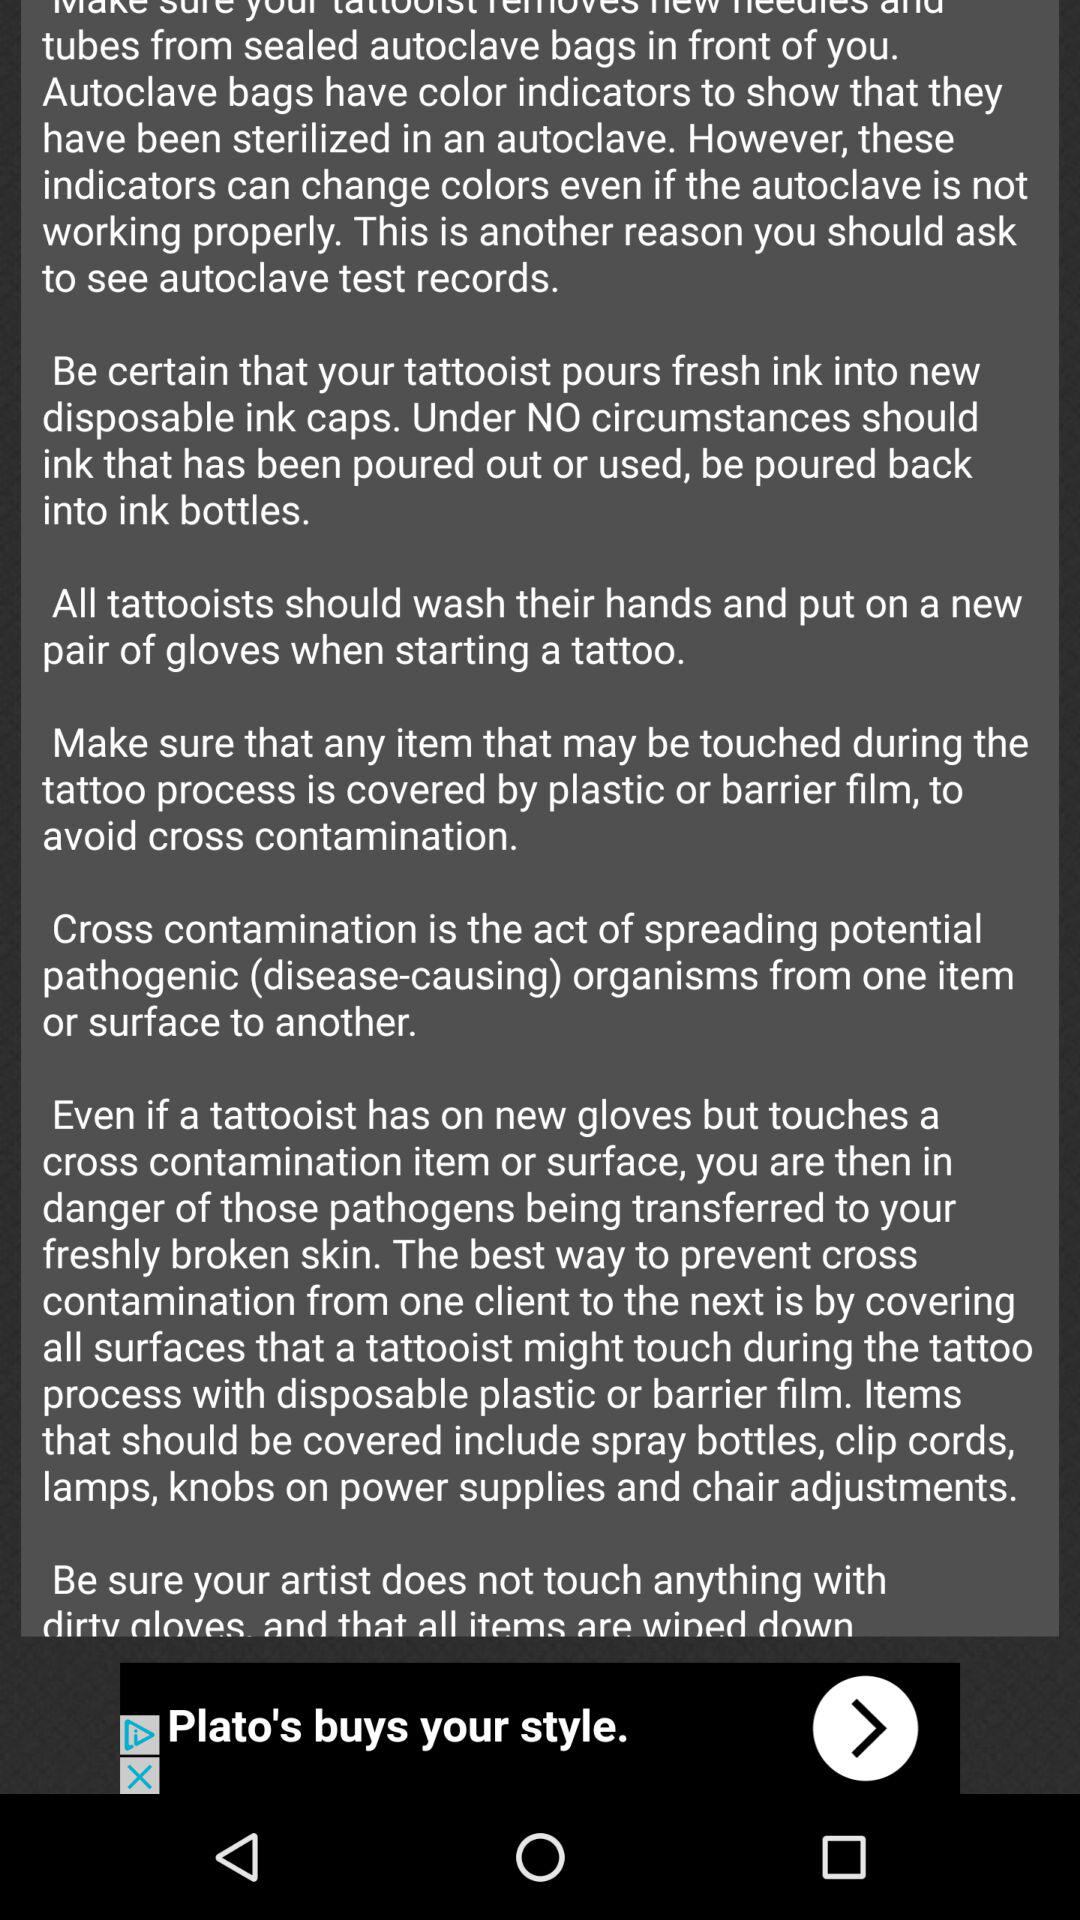How many text blocks are there on this page?
Answer the question using a single word or phrase. 7 